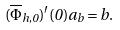Convert formula to latex. <formula><loc_0><loc_0><loc_500><loc_500>( \overline { \Phi } _ { h , 0 } ) ^ { \prime } ( 0 ) a _ { b } = b .</formula> 